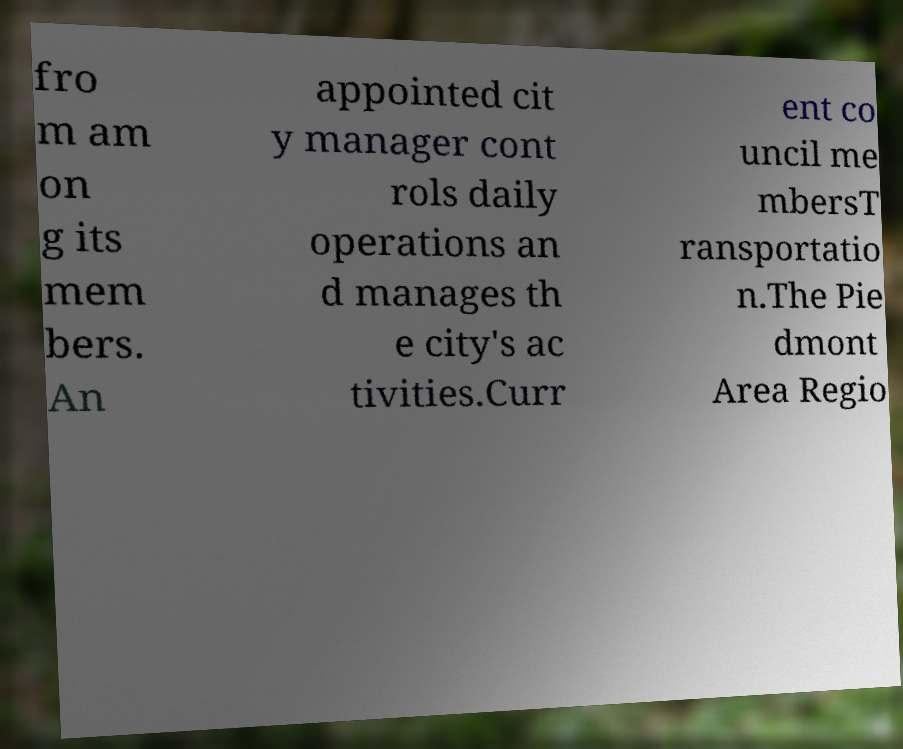Could you extract and type out the text from this image? fro m am on g its mem bers. An appointed cit y manager cont rols daily operations an d manages th e city's ac tivities.Curr ent co uncil me mbersT ransportatio n.The Pie dmont Area Regio 